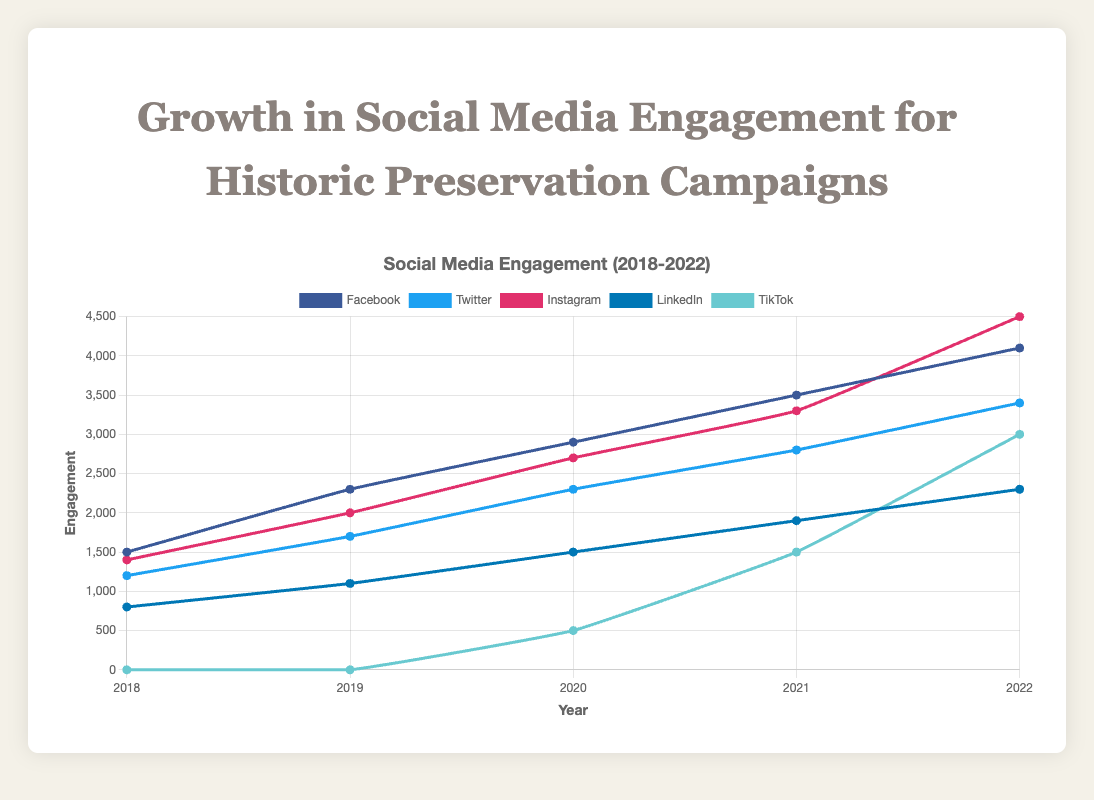How has Facebook engagement grown over the years? To determine the growth of Facebook engagement, we look at the engagement values for each year: 1500 in 2018, 2300 in 2019, 2900 in 2020, 3500 in 2021, and 4100 in 2022. This shows a consistent upward trend year-over-year.
Answer: Consistently upward Which platform saw the highest engagement in 2022? In 2022, the platform with the highest engagement is Instagram with an engagement value of 4500, compared to Facebook (4100), Twitter (3400), LinkedIn (2300), and TikTok (3000).
Answer: Instagram What is the total engagement for TikTok from 2020 to 2022? Summing up the engagement values for TikTok from 2020 (500) to 2022 (3000), we have 500 + 1500 + 3000 = 5000.
Answer: 5000 Which platform had the least growth in engagement over the five years? Comparing the growth from 2018 to 2022, LinkedIn started with 800 and ended with 2300, which is an increase of 1500. While TikTok started from 0, it grew the most in absolute terms. Thus, LinkedIn had the least growth.
Answer: LinkedIn In which year did Instagram surpass Facebook in engagement? Instagram engagement surpassed Facebook in 2022, where Instagram had 4500 engagements compared to Facebook's 4100.
Answer: 2022 What is the average engagement for Twitter over the five years? To find the average engagement for Twitter, sum the values for each year (1200 + 1700 + 2300 + 2800 + 3400 = 11400) and divide by the number of years (5). The average is 11400 / 5 = 2280.
Answer: 2280 How does the engagement trend for TikTok from 2020 to 2022 compare to the trend for LinkedIn in the same period? From 2020 to 2022, TikTok's engagement values rose from 500 to 1500 to 3000, showing a sharp upward trend. LinkedIn's engagement values increased from 1500 to 1900 to 2300, indicating a more gradual increase.
Answer: TikTok had a sharper increase Which platforms had a higher engagement than LinkedIn in 2021? In 2021, engagement for each platform was: Facebook (3500), Twitter (2800), Instagram (3300), LinkedIn (1900), and TikTok (1500). Thus, Facebook, Twitter, and Instagram had higher engagements than LinkedIn.
Answer: Facebook, Twitter, Instagram Between 2019 and 2020, which platform saw the greatest proportional increase in engagement? The proportional increase can be determined by taking the difference between 2020 and 2019 engagements and dividing by the 2019 amount. TikTok, starting from 0 in 2019 to 500 in 2020, technically has the largest proportional gain. Among platforms with non-zero starting values, Facebook increased from 2300 to 2900, approximately 26.1% increase. Instagram increased from 2000 to 2700, a 35% increase, making Instagram the next largest proportional increase.
Answer: TikTok (Instagram excluding zero-basis growth) What is the combined engagement of all platforms in 2021? Summing the 2021 engagement values for all platforms: Facebook (3500) + Twitter (2800) + Instagram (3300) + LinkedIn (1900) + TikTok (1500) = 13000.
Answer: 13000 